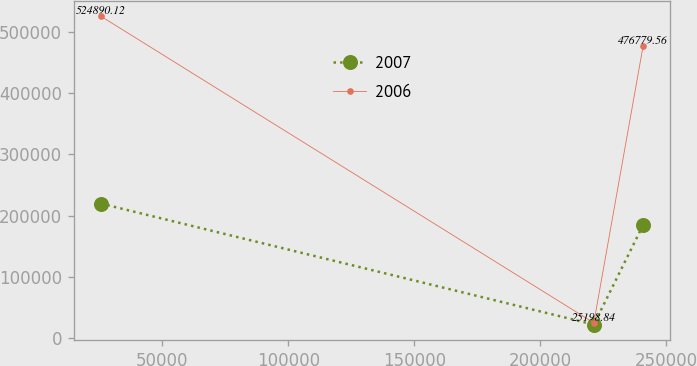<chart> <loc_0><loc_0><loc_500><loc_500><line_chart><ecel><fcel>2007<fcel>2006<nl><fcel>25681.1<fcel>219653<fcel>524890<nl><fcel>221254<fcel>22396<fcel>25198.8<nl><fcel>240831<fcel>184768<fcel>476780<nl></chart> 